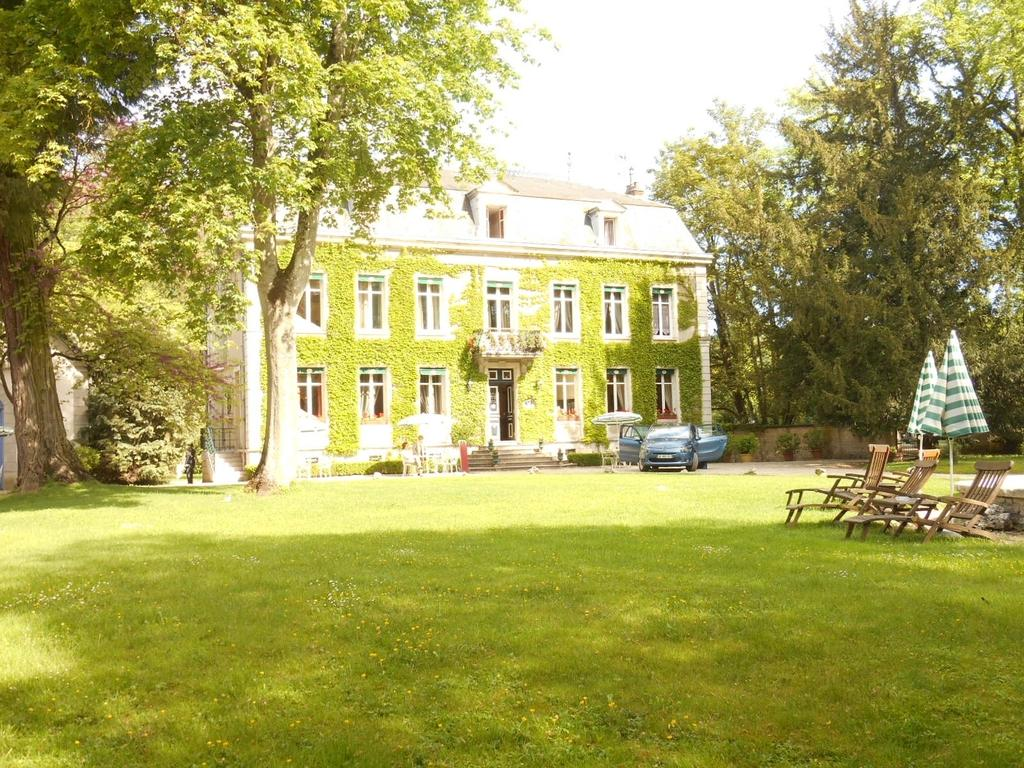What type of structure is visible in the image? There is a house in the image. What type of vegetation is present in the image? There are trees in the image. What type of furniture is visible in the image? There are chairs in the image. What type of vehicle is present in the image? There is a car in the image. What type of architectural feature is present in the image? There are stairs in the image. What type of accessory is present in the image? There are umbrellas in the image. What part of the natural environment is visible in the image? The sky is visible at the top of the image, and the ground is visible at the bottom of the image. What type of religious symbol is present in the image? There is no religious symbol present in the image. How does the carriage fit into the image? There is no carriage present in the image. 